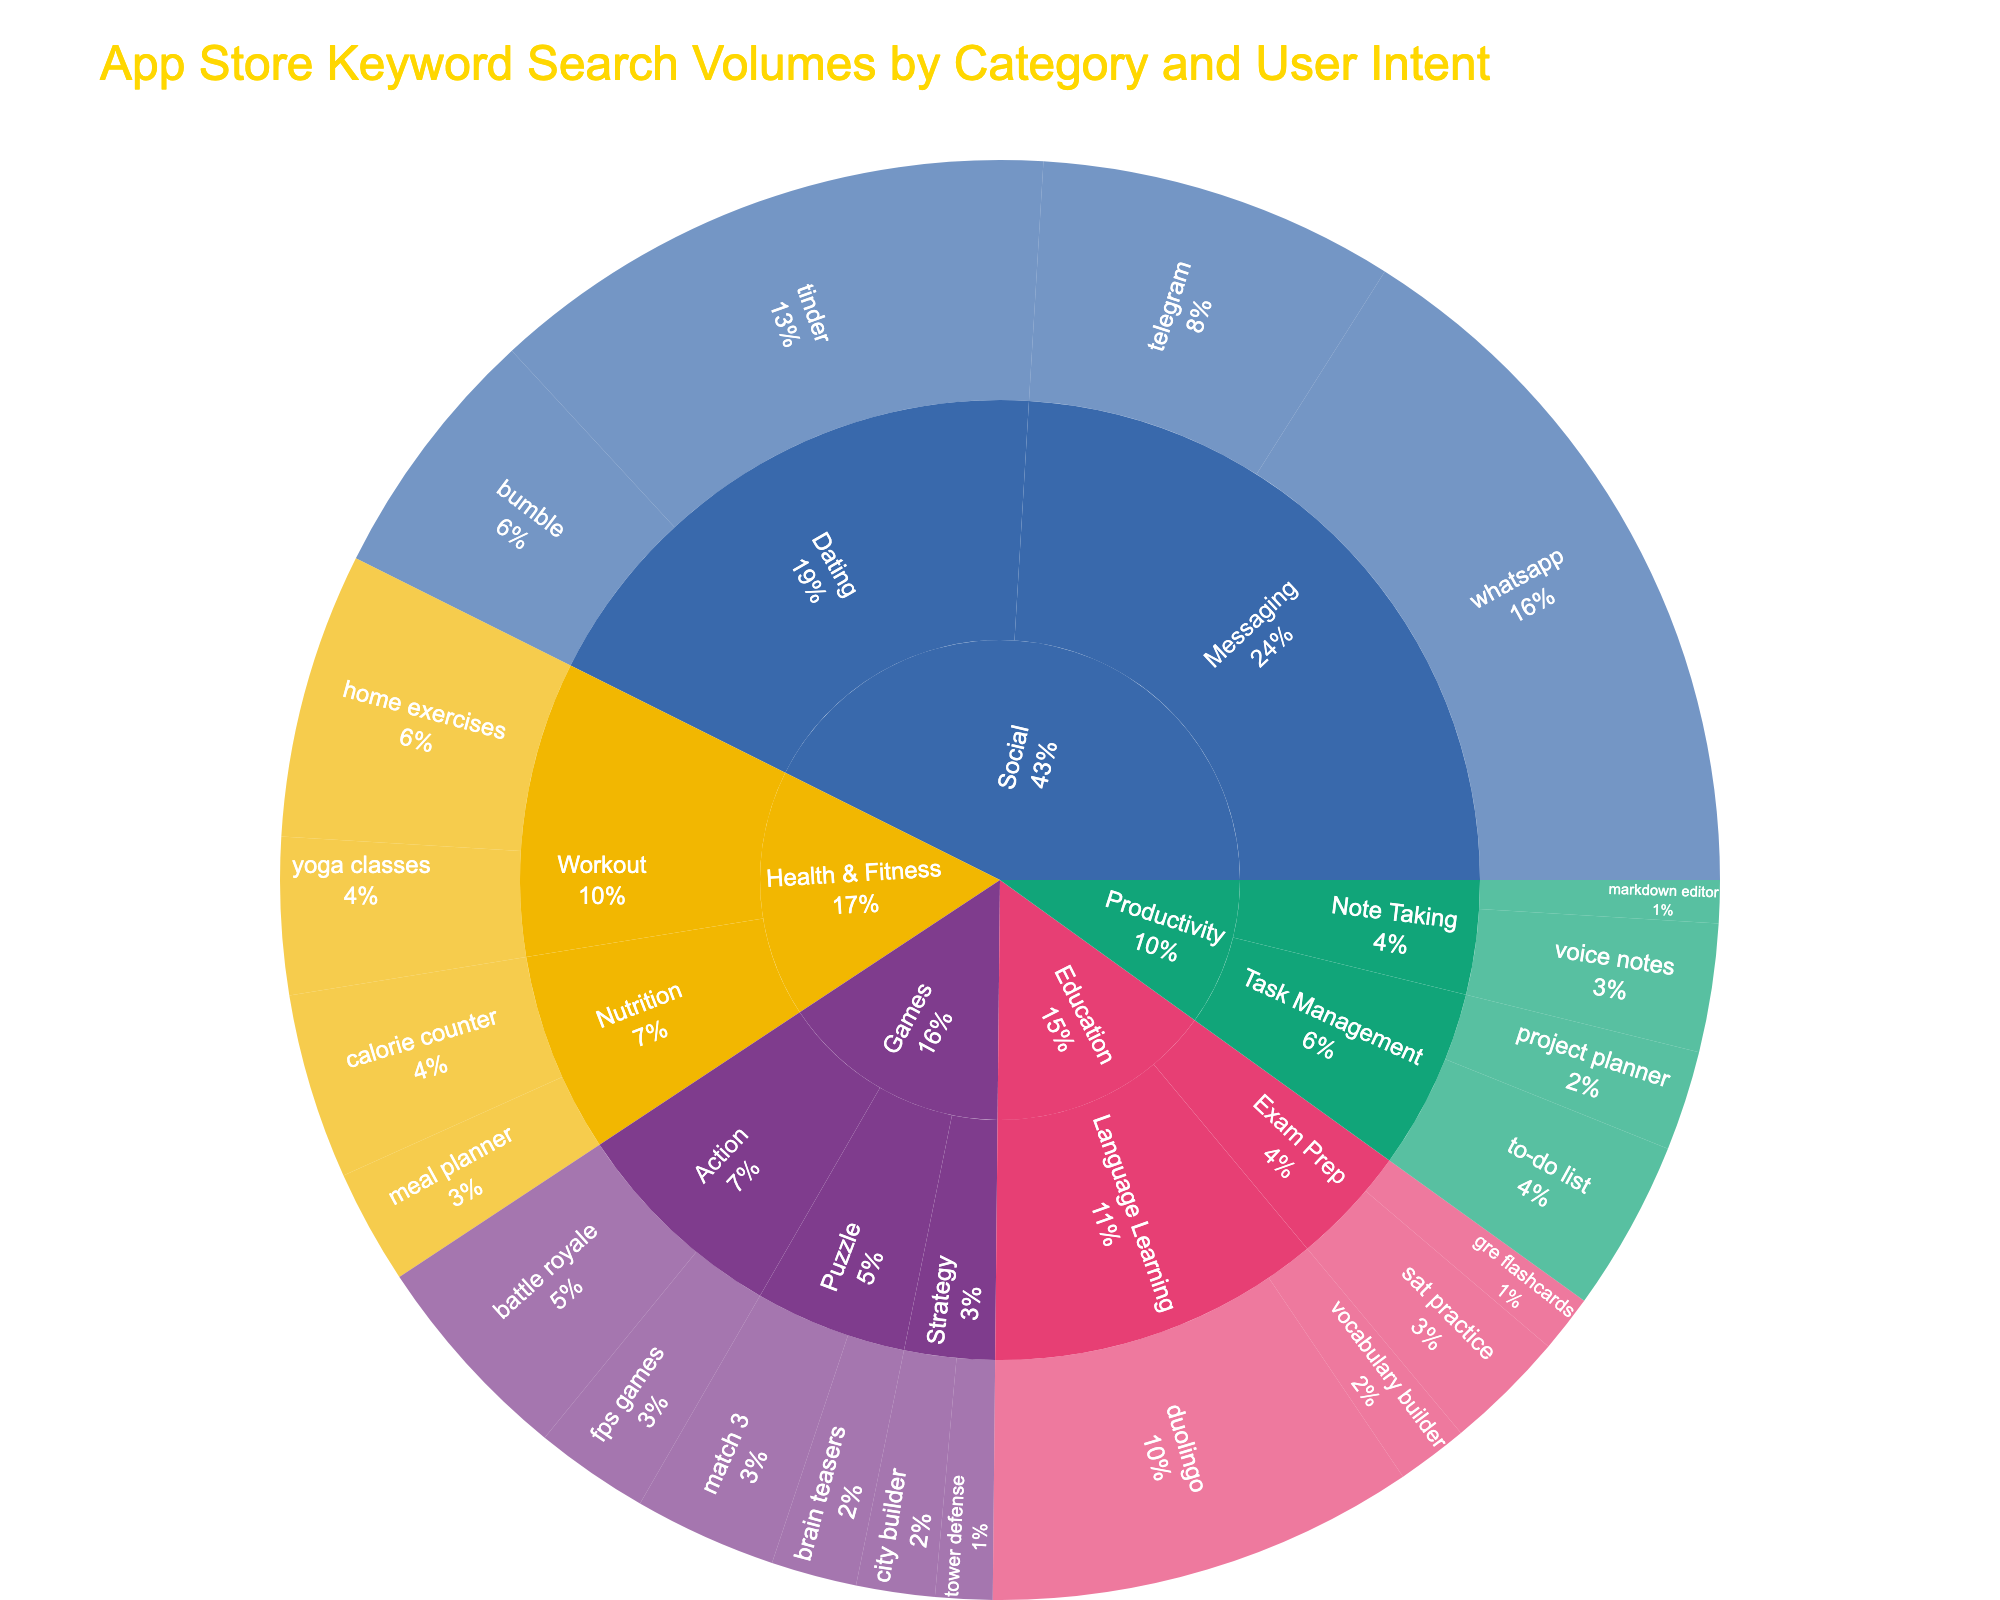What's the title of the Sunburst Plot? The title is typically indicated at the top of the plot. It summarises the main theme of the visualised data.
Answer: App Store Keyword Search Volumes by Category and User Intent What color represents the 'Games' category? Categories in a Sunburst Plot are often color-coded distinctly. In this case, the representation color for the 'Games' category can be identified by observing the corresponding section.
Answer: Bold color assigned to 'Games' Which keyword in the 'Workout' subcategory has the highest search volume? By observing the 'Workout' division under the 'Health & Fitness' category, we can compare the search volumes of the keywords listed there. The one with the largest section denotes the highest search volume.
Answer: Home exercises Between 'tinder' and 'bumble', which dating app keyword has a higher search volume? Observe the sections under the 'Dating' subcategory within the 'Social' category and compare the sizes and search volumes of 'tinder' and 'bumble'.
Answer: Tinder What is the search volume for 'project planner'? Locate the 'project planner' keyword under the 'Task Management' subcategory in the 'Productivity' category and check its search volume.
Answer: 70,000 How many keywords are there under the 'Education' category? Identify the 'Education' category, then count the distinct keywords within its subcategories.
Answer: 4 Which subcategory in the 'Productivity' category has more search volume, 'Task Management' or 'Note Taking'? Sum the search volumes of keywords in both subcategories under 'Productivity' and compare the totals.
Answer: Task Management What percentage of search volume does the 'Language Learning' subcategory cover within the 'Education' category? Sum the search volumes of keywords in 'Language Learning', find the total for 'Education', and compute the percentage share.
Answer: (300,000 + 50,000) / (300,000 + 50,000 + 85,000 + 40,000) ≈ 71.4% List the top three keywords with the highest search volumes. Look at all keywords represented in the Sunburst Plot and identify the three largest segments.
Answer: whatsapp, tinder, duolingo Which category has the least total search volume? Calculate the total search volume for each category by summing the search volumes of associated keywords and then identify the smallest total.
Answer: Games 